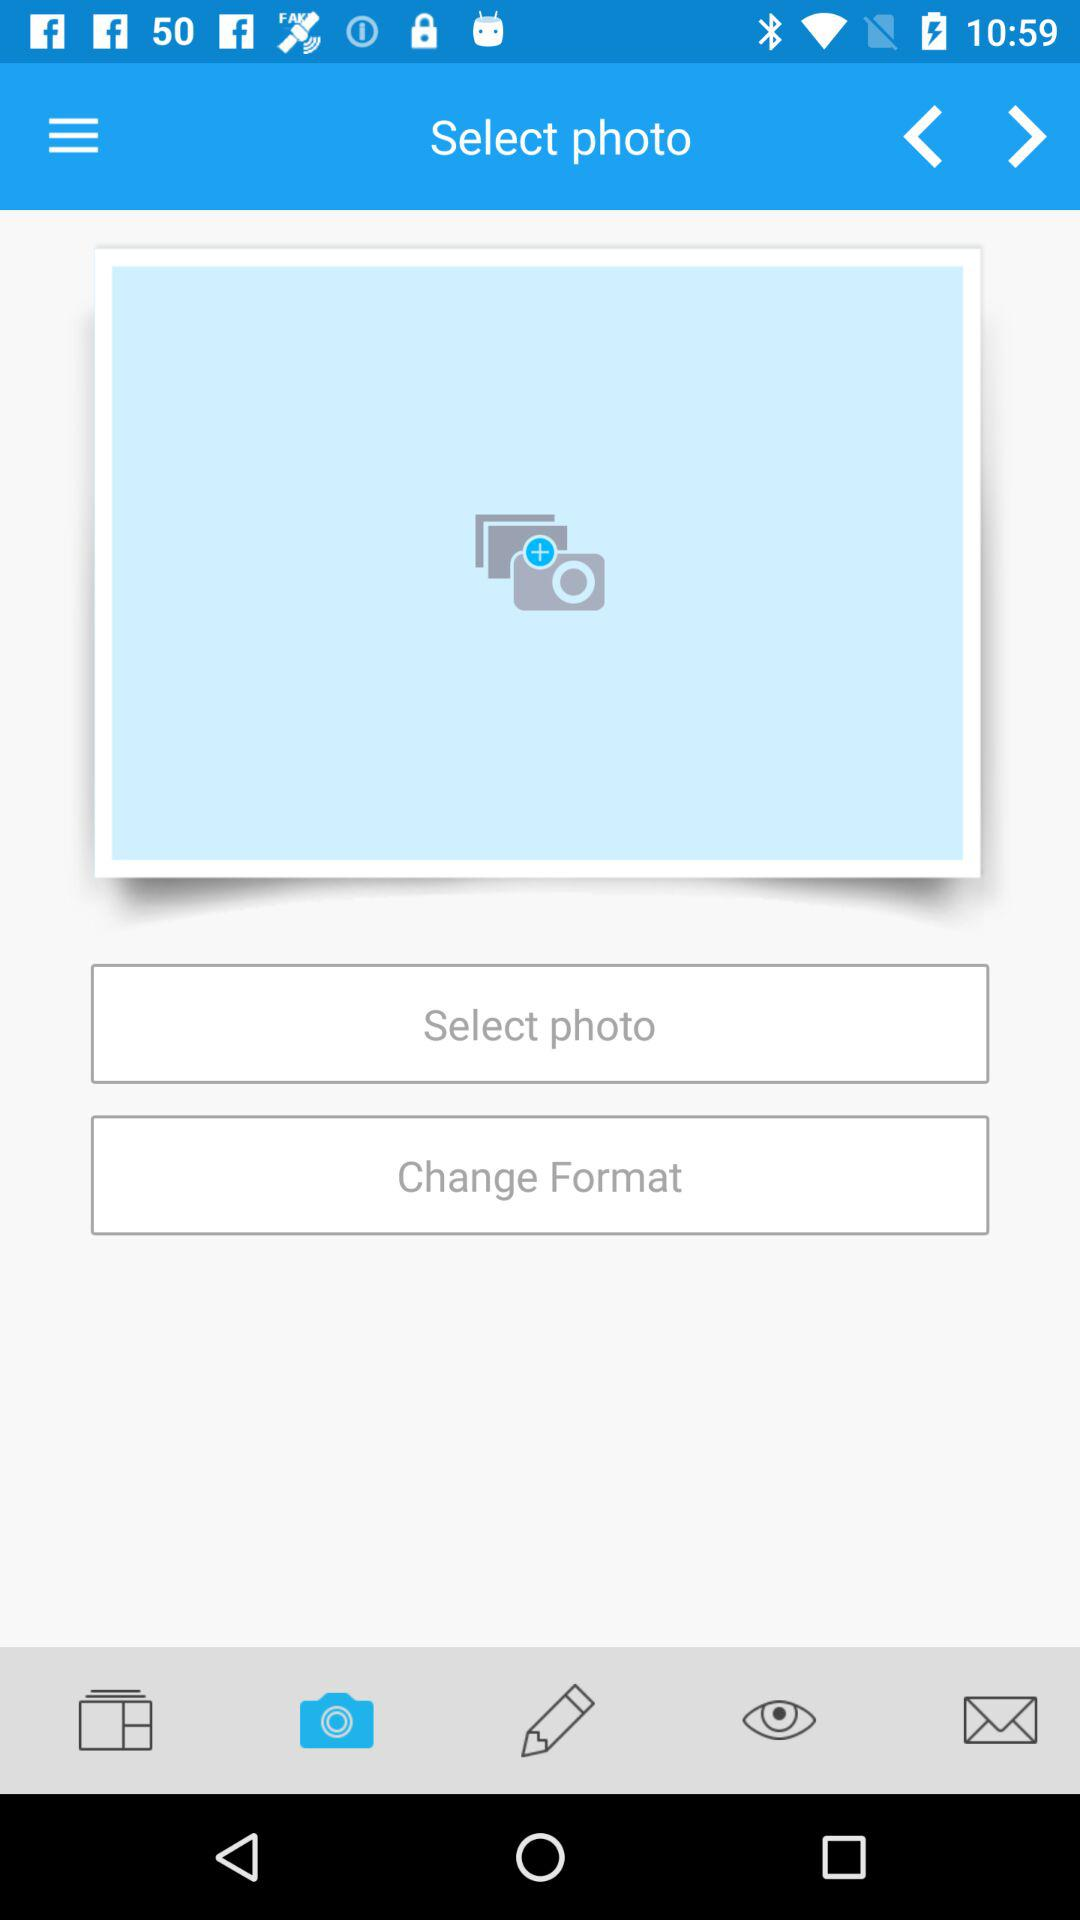Which photo was selected?
When the provided information is insufficient, respond with <no answer>. <no answer> 